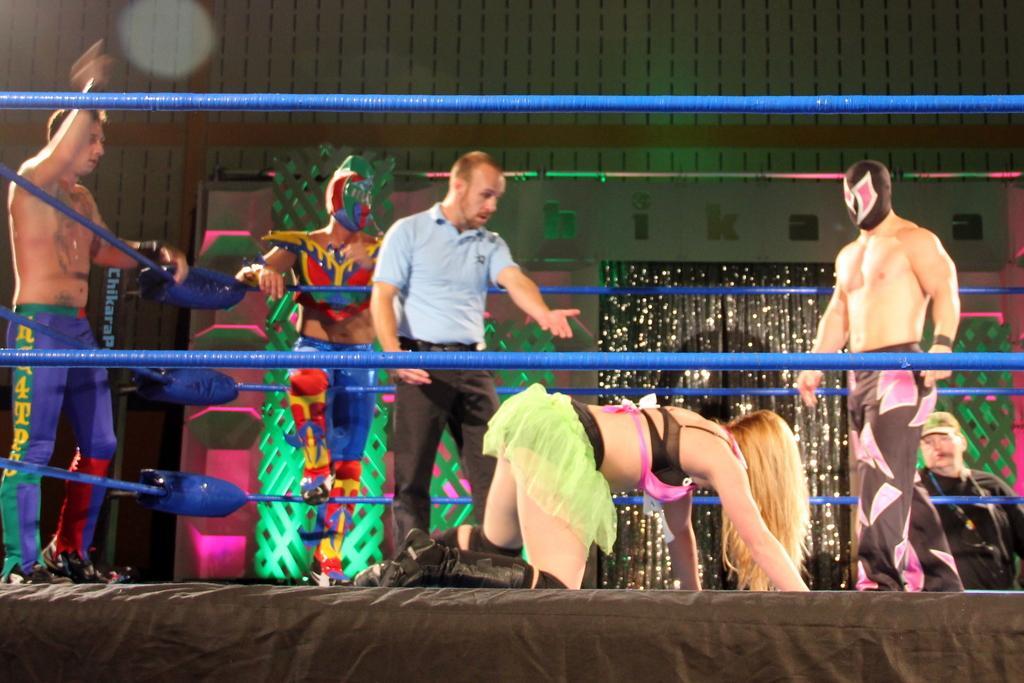Could you give a brief overview of what you see in this image? In the middle of the image, there is a woman in a light green color skirt, kneeling down and keeping both hands on a stage. This stage is having blue color threads as a fence. Beside her, there are two persons standing. Outside these blue color threads, there are two persons standing. In the background, there are lights arranged and there is a wall. 